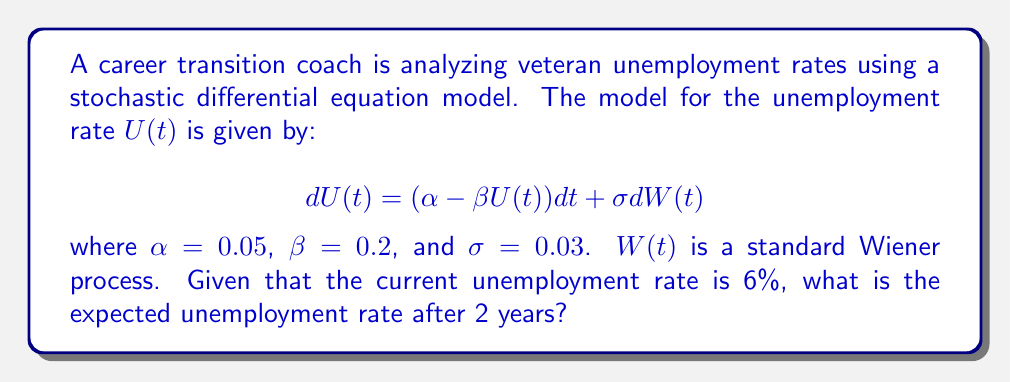Can you answer this question? To solve this problem, we need to follow these steps:

1) The given stochastic differential equation is a mean-reverting Ornstein-Uhlenbeck process. The mean-reverting level is $\frac{\alpha}{\beta}$.

2) For an Ornstein-Uhlenbeck process, the expected value at time t, given an initial value $U(0)$, is:

   $$E[U(t)|U(0)] = \frac{\alpha}{\beta} + (U(0) - \frac{\alpha}{\beta})e^{-\beta t}$$

3) Let's calculate the mean-reverting level:
   
   $$\frac{\alpha}{\beta} = \frac{0.05}{0.2} = 0.25 = 25\%$$

4) Now, let's plug in our values:
   - $U(0) = 6\% = 0.06$ (initial unemployment rate)
   - $t = 2$ (years)
   - $\alpha = 0.05$
   - $\beta = 0.2$

5) Substituting into our formula:

   $$E[U(2)|U(0)] = 0.25 + (0.06 - 0.25)e^{-0.2 * 2}$$

6) Simplify:
   
   $$E[U(2)|U(0)] = 0.25 + (-0.19)e^{-0.4}$$
   $$E[U(2)|U(0)] = 0.25 - 0.19 * 0.6703$$
   $$E[U(2)|U(0)] = 0.25 - 0.1274 = 0.1226$$

7) Convert to percentage:
   
   $$E[U(2)|U(0)] = 12.26\%$$
Answer: 12.26% 